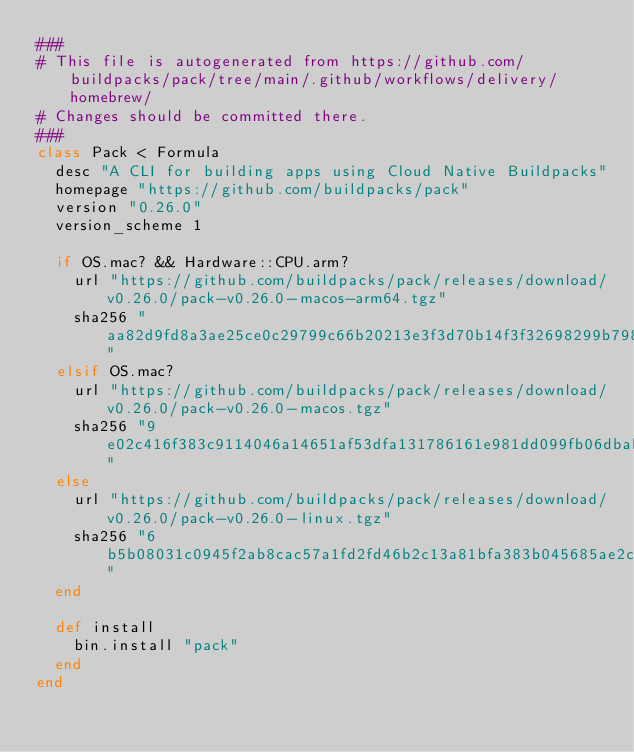<code> <loc_0><loc_0><loc_500><loc_500><_Ruby_>###
# This file is autogenerated from https://github.com/buildpacks/pack/tree/main/.github/workflows/delivery/homebrew/
# Changes should be committed there. 
###
class Pack < Formula
  desc "A CLI for building apps using Cloud Native Buildpacks"
  homepage "https://github.com/buildpacks/pack"
  version "0.26.0"
  version_scheme 1

  if OS.mac? && Hardware::CPU.arm?
    url "https://github.com/buildpacks/pack/releases/download/v0.26.0/pack-v0.26.0-macos-arm64.tgz"
    sha256 "aa82d9fd8a3ae25ce0c29799c66b20213e3f3d70b14f3f32698299b798617e6a"
  elsif OS.mac?
    url "https://github.com/buildpacks/pack/releases/download/v0.26.0/pack-v0.26.0-macos.tgz"
    sha256 "9e02c416f383c9114046a14651af53dfa131786161e981dd099fb06dbab7ecc1"
  else 
    url "https://github.com/buildpacks/pack/releases/download/v0.26.0/pack-v0.26.0-linux.tgz"
    sha256 "6b5b08031c0945f2ab8cac57a1fd2fd46b2c13a81bfa383b045685ae2cf5d2f5"
  end

  def install
    bin.install "pack"
  end
end
</code> 